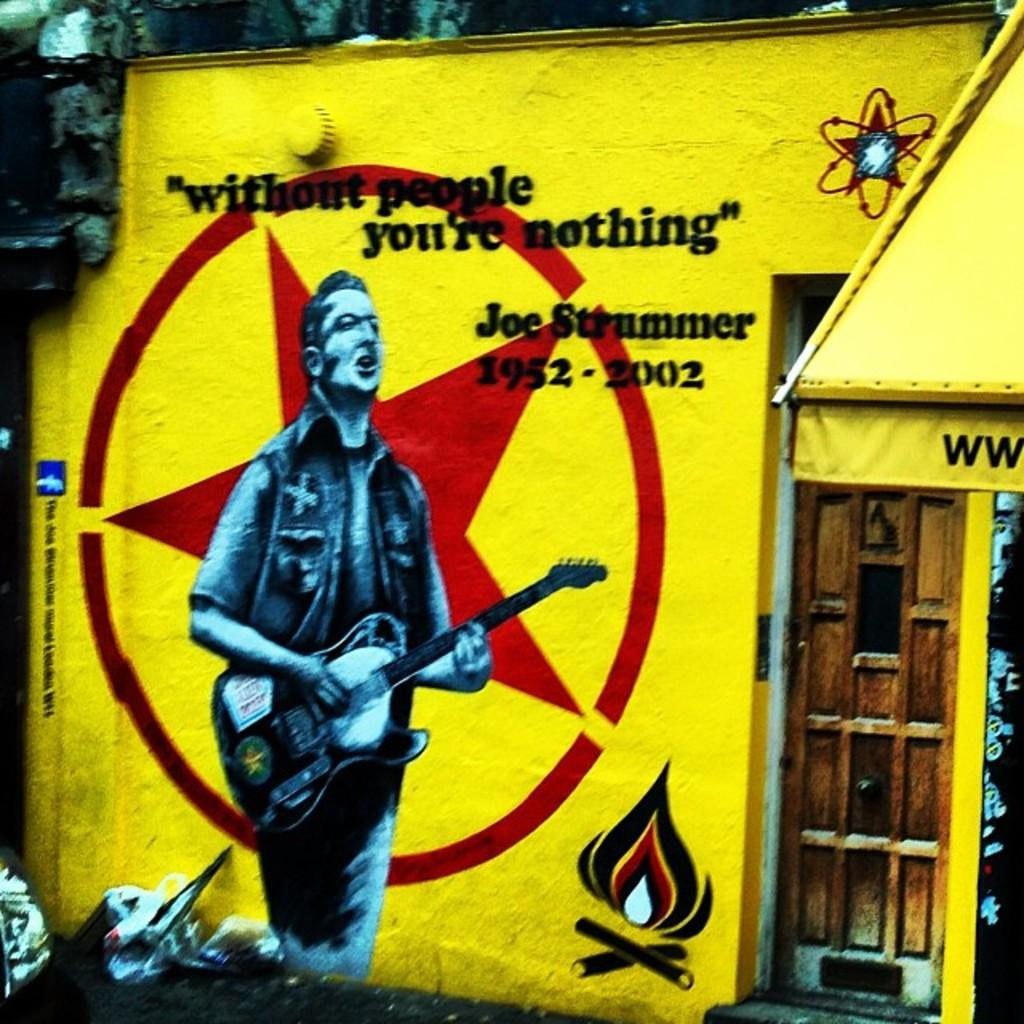<image>
Present a compact description of the photo's key features. the outside of a building with a quote on it that says 'without people you're nothing" 